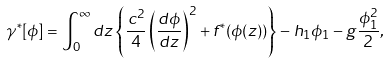<formula> <loc_0><loc_0><loc_500><loc_500>\gamma ^ { * } [ \phi ] = \int _ { 0 } ^ { \infty } d z \left \{ \frac { c ^ { 2 } } { 4 } \left ( \frac { d \phi } { d z } \right ) ^ { 2 } + f ^ { * } ( \phi ( z ) ) \right \} - h _ { 1 } \phi _ { 1 } - g \frac { \phi _ { 1 } ^ { 2 } } { 2 } ,</formula> 